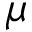Convert formula to latex. <formula><loc_0><loc_0><loc_500><loc_500>\mu</formula> 